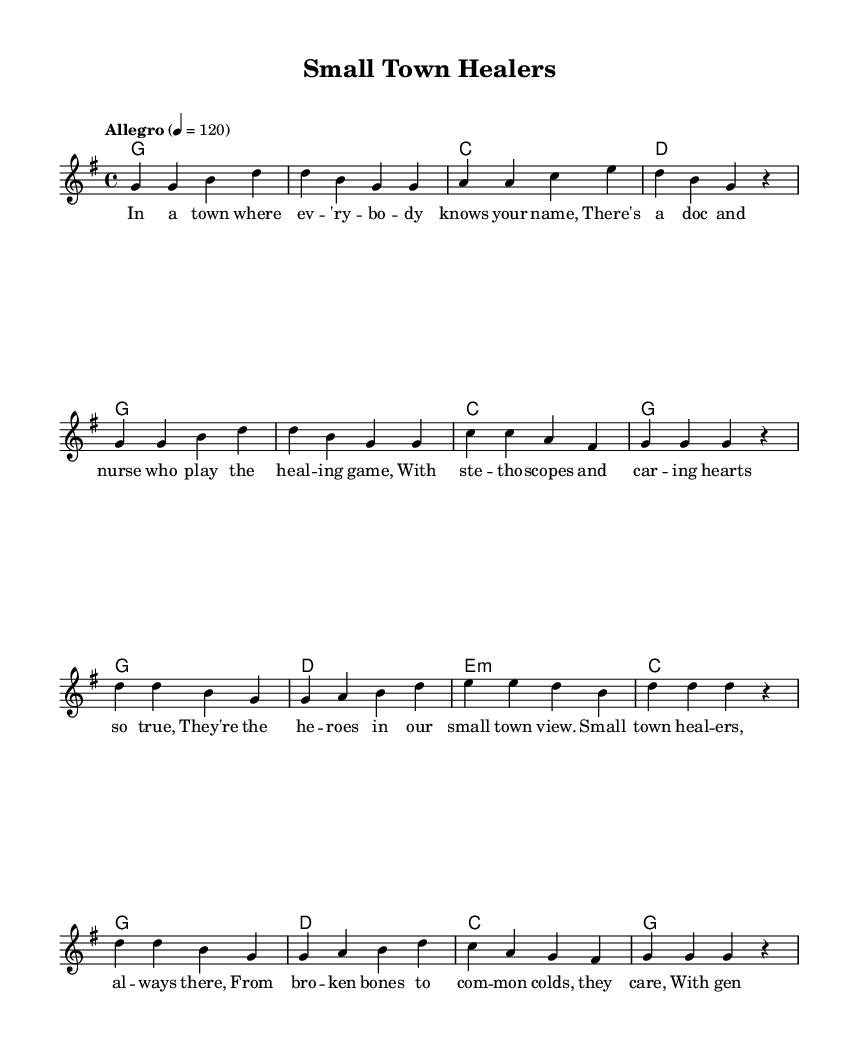What is the key signature of this music? The key signature is G major, which contains one sharp (F#). You can identify the key signature by looking at the notation at the beginning of the sheet music.
Answer: G major What is the time signature of this music? The time signature is 4/4, which indicates there are four beats in each measure and the quarter note gets one beat. This can be found at the beginning of the music right after the key signature.
Answer: 4/4 What is the tempo marking of this piece? The tempo marking is "Allegro" indicated at the beginning of the sheet music, which means to play at a fast, lively pace. The metronome marking 4 = 120 indicates a speed of 120 beats per minute.
Answer: Allegro How many measures are in the verse? There are 8 measures in the verse section of the music. You can count the number of horizontal lines that form the measures for the verse, starting from the first note in the melody to the end of the verse.
Answer: 8 What instruments are indicated in the score? The score indicates a single staff with a voice for melody and chord names for harmonic support. There are no additional instruments indicated in the score, as the primary focus is on the melody and harmonies provided.
Answer: Voice and Chord Names What is the structure of the song? The structure consists of a verse followed by a chorus, repeated in that order. The verse introduces the storyline, while the chorus provides a summary or emotional reflection of that story. You can see the lyrics aligned under the melody to illustrate this structure.
Answer: Verse and Chorus 